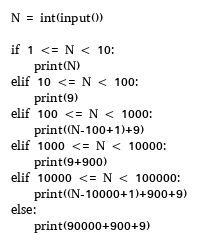Convert code to text. <code><loc_0><loc_0><loc_500><loc_500><_Python_>N = int(input())

if 1 <= N < 10:
    print(N)
elif 10 <= N < 100:
    print(9)
elif 100 <= N < 1000:
    print((N-100+1)+9)
elif 1000 <= N < 10000:
    print(9+900)
elif 10000 <= N < 100000:
    print((N-10000+1)+900+9)
else:
    print(90000+900+9)
</code> 